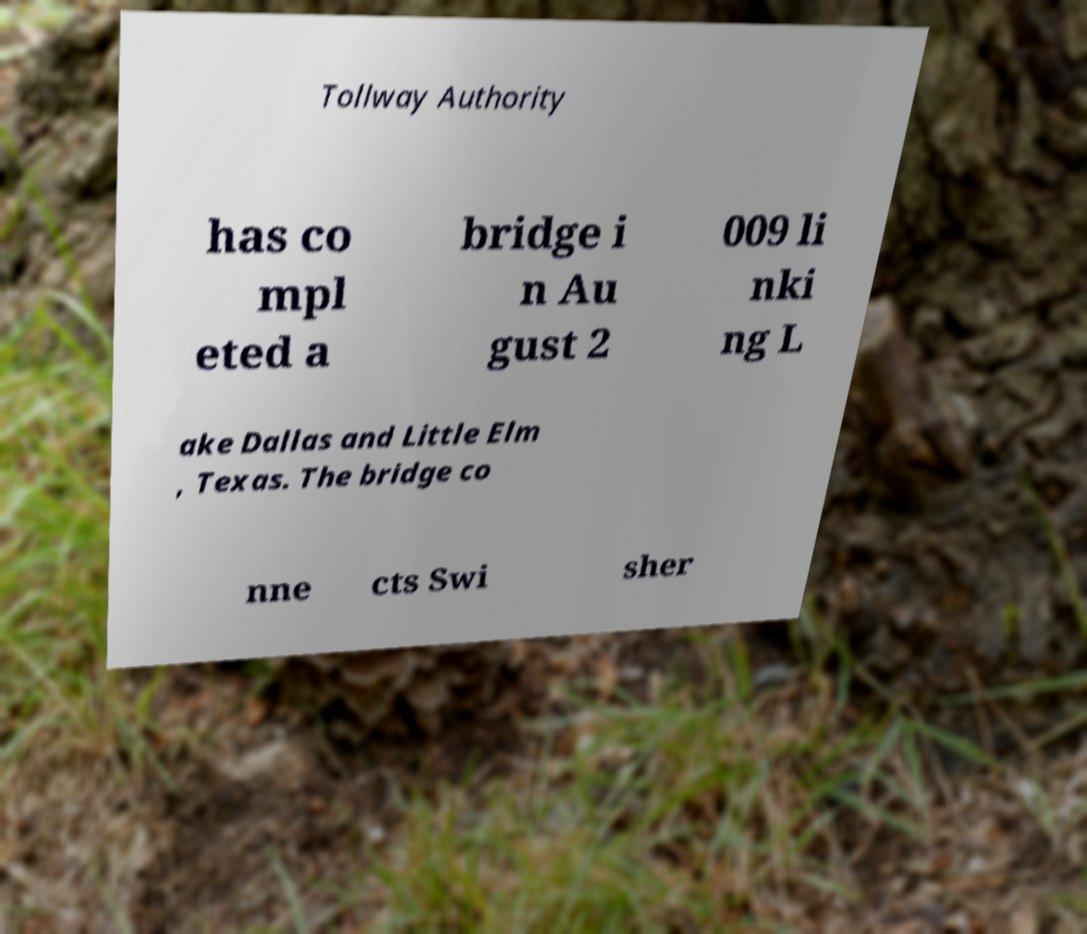Could you extract and type out the text from this image? Tollway Authority has co mpl eted a bridge i n Au gust 2 009 li nki ng L ake Dallas and Little Elm , Texas. The bridge co nne cts Swi sher 